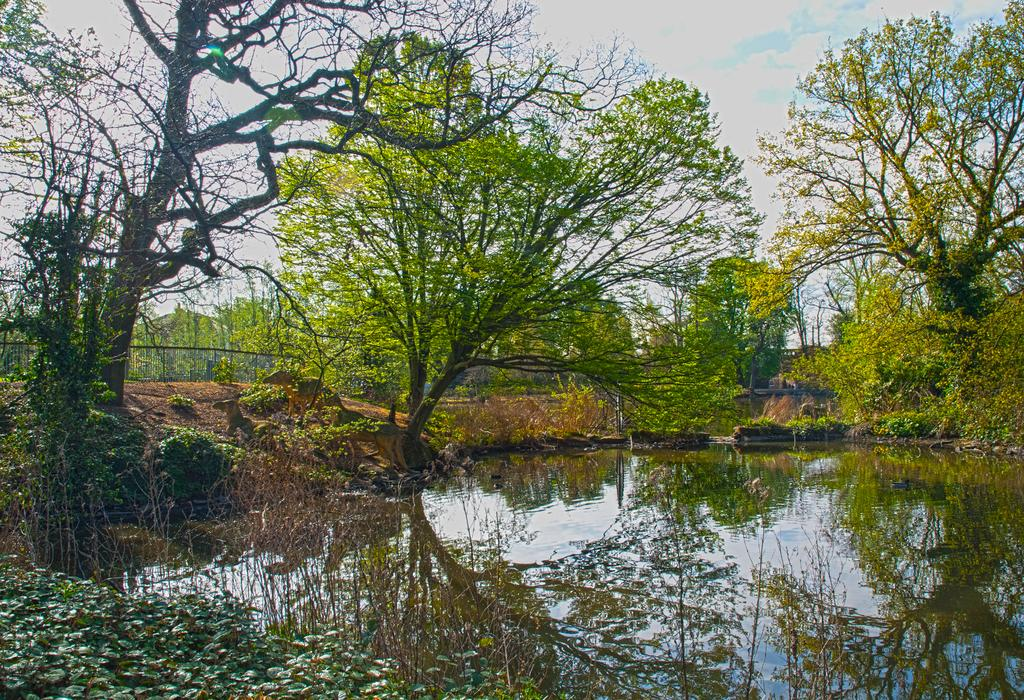What is the primary element visible in the image? There is water in the image. What type of vegetation can be seen in the image? There are trees and plants in the image. What part of the natural environment is visible in the background of the image? The sky is visible in the background of the image. Can you see the mother holding the chain and wing in the image? There is no mother, chain, or wing present in the image. 